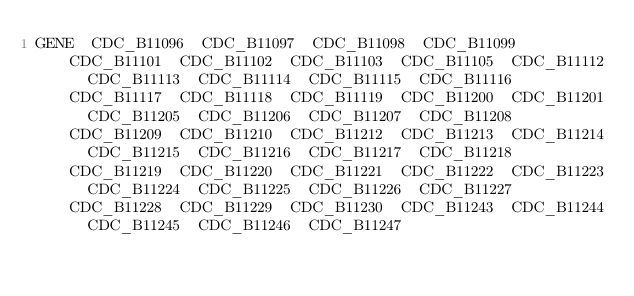<code> <loc_0><loc_0><loc_500><loc_500><_SQL_>GENE	CDC_B11096	CDC_B11097	CDC_B11098	CDC_B11099	CDC_B11101	CDC_B11102	CDC_B11103	CDC_B11105	CDC_B11112	CDC_B11113	CDC_B11114	CDC_B11115	CDC_B11116	CDC_B11117	CDC_B11118	CDC_B11119	CDC_B11200	CDC_B11201	CDC_B11205	CDC_B11206	CDC_B11207	CDC_B11208	CDC_B11209	CDC_B11210	CDC_B11212	CDC_B11213	CDC_B11214	CDC_B11215	CDC_B11216	CDC_B11217	CDC_B11218	CDC_B11219	CDC_B11220	CDC_B11221	CDC_B11222	CDC_B11223	CDC_B11224	CDC_B11225	CDC_B11226	CDC_B11227	CDC_B11228	CDC_B11229	CDC_B11230	CDC_B11243	CDC_B11244	CDC_B11245	CDC_B11246	CDC_B11247</code> 